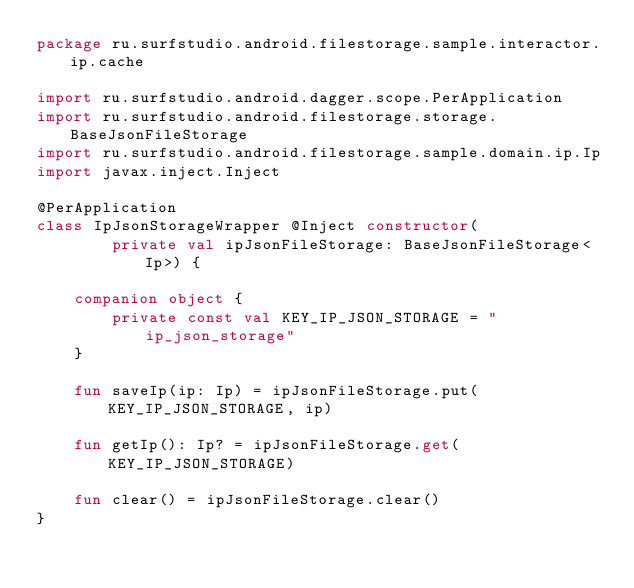<code> <loc_0><loc_0><loc_500><loc_500><_Kotlin_>package ru.surfstudio.android.filestorage.sample.interactor.ip.cache

import ru.surfstudio.android.dagger.scope.PerApplication
import ru.surfstudio.android.filestorage.storage.BaseJsonFileStorage
import ru.surfstudio.android.filestorage.sample.domain.ip.Ip
import javax.inject.Inject

@PerApplication
class IpJsonStorageWrapper @Inject constructor(
        private val ipJsonFileStorage: BaseJsonFileStorage<Ip>) {

    companion object {
        private const val KEY_IP_JSON_STORAGE = "ip_json_storage"
    }

    fun saveIp(ip: Ip) = ipJsonFileStorage.put(KEY_IP_JSON_STORAGE, ip)

    fun getIp(): Ip? = ipJsonFileStorage.get(KEY_IP_JSON_STORAGE)

    fun clear() = ipJsonFileStorage.clear()
}</code> 